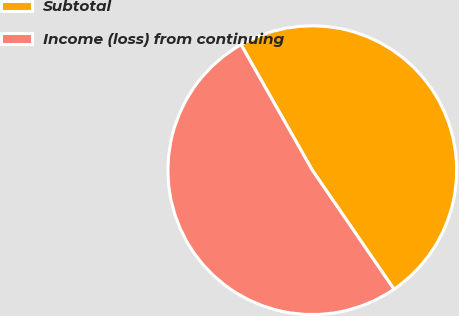<chart> <loc_0><loc_0><loc_500><loc_500><pie_chart><fcel>Subtotal<fcel>Income (loss) from continuing<nl><fcel>48.65%<fcel>51.35%<nl></chart> 